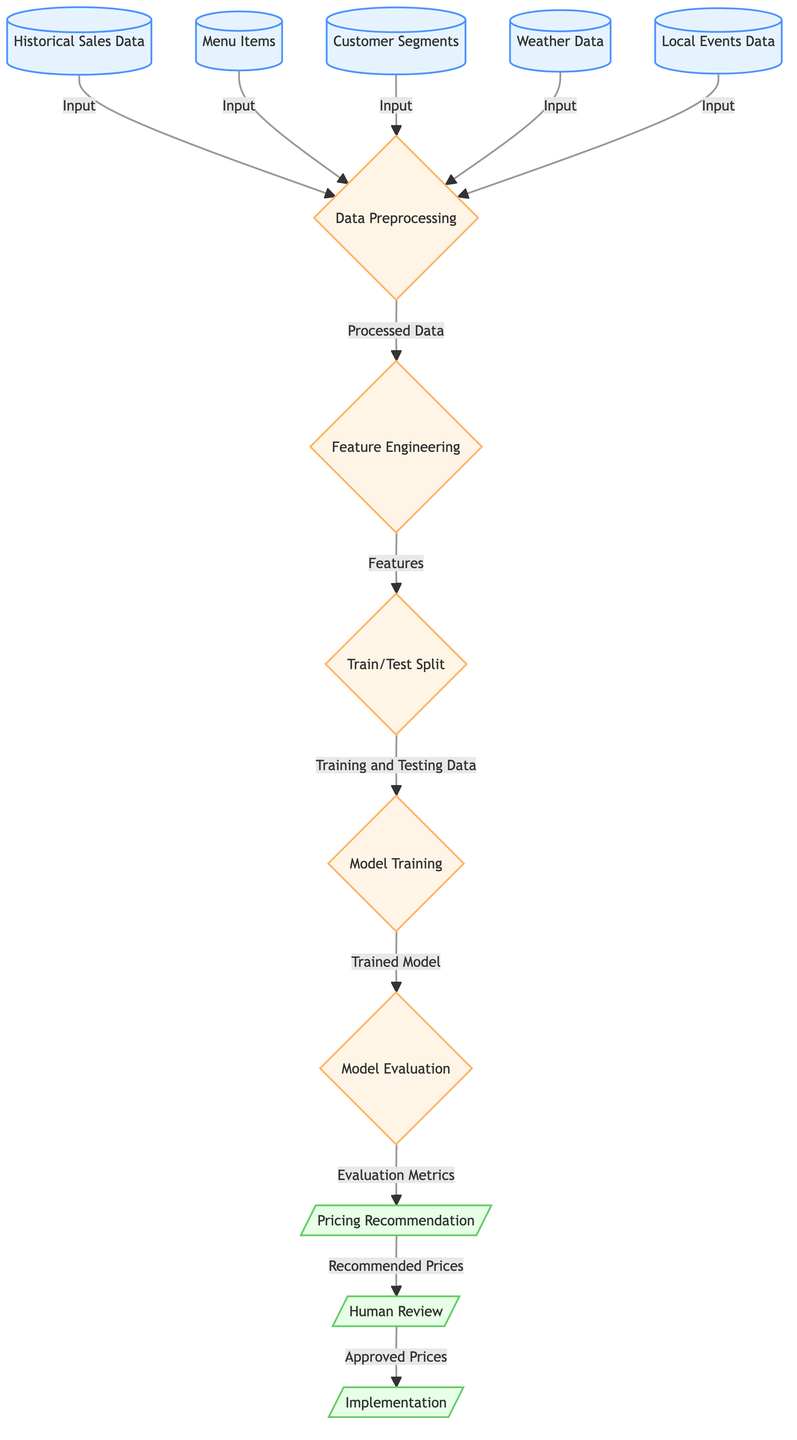What is the first input to the diagram? The first input is the "Historical Sales Data," which connects to the "Data Preprocessing" process.
Answer: Historical Sales Data How many input nodes are present in the diagram? Counting the nodes that provide input to the "Data Preprocessing," there are five: historical data, menu items, customer segments, weather data, and local events data.
Answer: 5 What is the last process step before the output? The last process step before output is "Model Evaluation," which assesses the performance of the trained model before making pricing recommendations.
Answer: Model Evaluation What type of output is generated from the pricing recommendation node? The "Pricing Recommendation" node generates "Recommended Prices," which are the outcomes of the model evaluation process.
Answer: Recommended Prices What type of data is primarily being analyzed for pricing recommendations? The diagram analyzes "Historical Sales Data" among other factors, which is key for pricing predictions.
Answer: Historical Sales Data Which node follows the "Model Evaluation" step? The node that follows "Model Evaluation" is "Pricing Recommendation," indicating the flow continues to generate price suggestions.
Answer: Pricing Recommendation How many total process nodes are shown in the diagram? The process nodes are composed of five: Data Preprocessing, Feature Engineering, Train/Test Split, Model Training, and Model Evaluation, giving a total of five process steps.
Answer: 5 What action occurs after the pricing recommendation node? After the pricing recommendation node, the action that occurs is "Human Review," where the suggested prices are evaluated by a human before implementation.
Answer: Human Review What is the final output of the entire process? The final output of the entire process is "Implementation," signifying that the approved prices derived from human review are put into action.
Answer: Implementation 